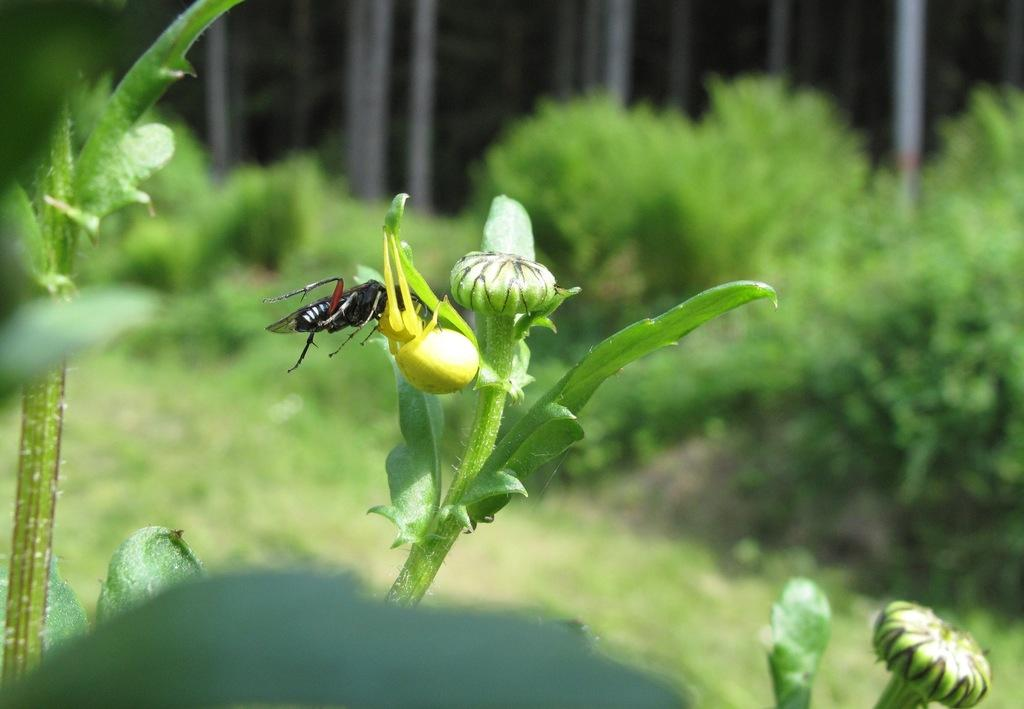What is on the bud of the plant in the image? There is an insect on the bud of a plant in the image. What features can be seen on the plant? The plant has leaves. What can be seen at the bottom of the image? There are other plants with buds and leaves at the bottom of the image. What is visible in the background of the image? There are plants on the land in the background of the image. What type of locket is hanging from the insect's chin in the image? There is no locket, spoon, or chin present in the image. The image features an insect on the bud of a plant, with other plants visible in the image. 